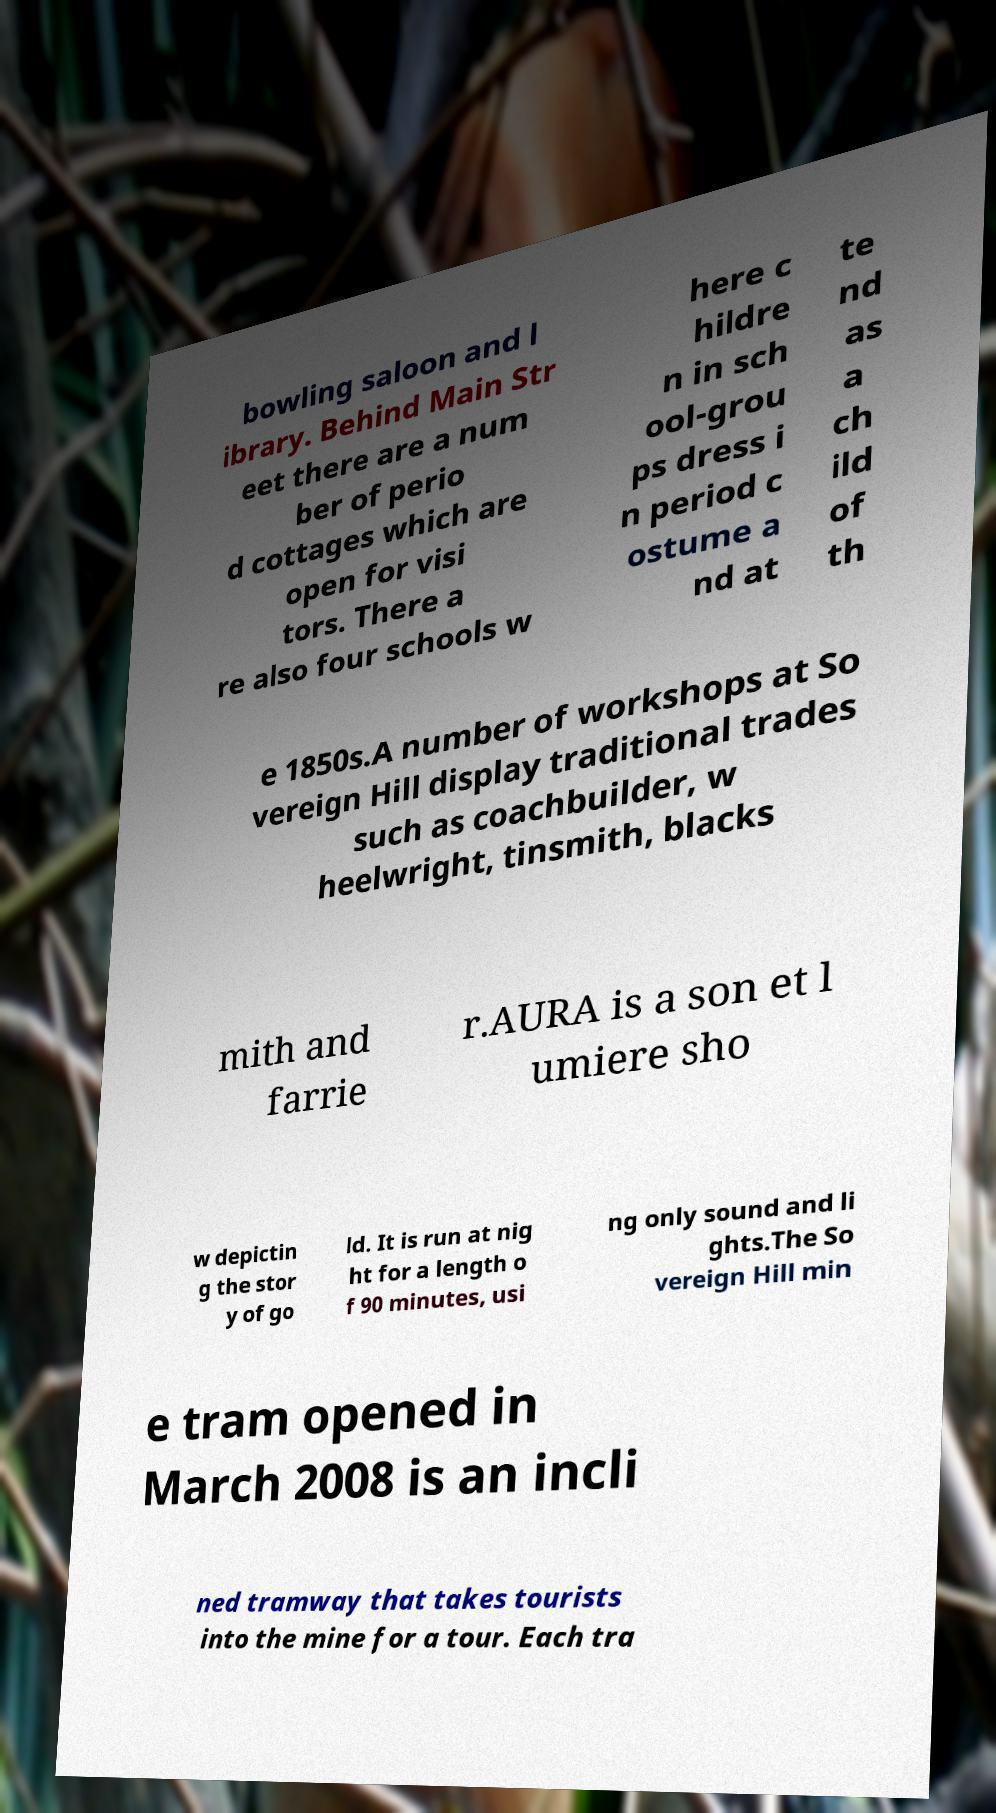Please identify and transcribe the text found in this image. bowling saloon and l ibrary. Behind Main Str eet there are a num ber of perio d cottages which are open for visi tors. There a re also four schools w here c hildre n in sch ool-grou ps dress i n period c ostume a nd at te nd as a ch ild of th e 1850s.A number of workshops at So vereign Hill display traditional trades such as coachbuilder, w heelwright, tinsmith, blacks mith and farrie r.AURA is a son et l umiere sho w depictin g the stor y of go ld. It is run at nig ht for a length o f 90 minutes, usi ng only sound and li ghts.The So vereign Hill min e tram opened in March 2008 is an incli ned tramway that takes tourists into the mine for a tour. Each tra 